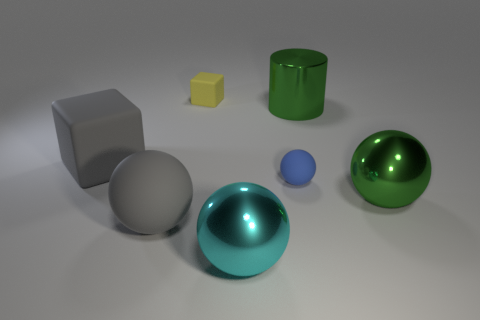How many things are blocks in front of the green shiny cylinder or large cubes?
Provide a short and direct response. 1. There is a yellow object; is it the same size as the metallic thing that is right of the cylinder?
Give a very brief answer. No. What is the size of the gray rubber thing that is the same shape as the small yellow rubber thing?
Keep it short and to the point. Large. There is a object on the left side of the big ball to the left of the yellow matte cube; how many green metallic objects are in front of it?
Your answer should be very brief. 1. What number of balls are either cyan objects or small matte objects?
Give a very brief answer. 2. There is a metallic ball that is to the left of the large sphere that is behind the large matte object that is in front of the big green sphere; what is its color?
Your answer should be very brief. Cyan. What number of other things are the same size as the green cylinder?
Ensure brevity in your answer.  4. Is there anything else that has the same shape as the yellow matte object?
Keep it short and to the point. Yes. What color is the other large rubber object that is the same shape as the blue rubber thing?
Provide a succinct answer. Gray. What is the color of the big cylinder that is the same material as the large green sphere?
Your response must be concise. Green. 